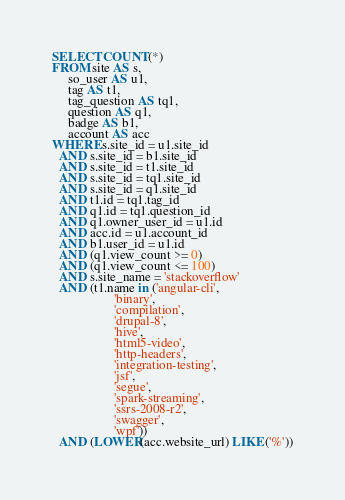Convert code to text. <code><loc_0><loc_0><loc_500><loc_500><_SQL_>SELECT COUNT(*)
FROM site AS s,
     so_user AS u1,
     tag AS t1,
     tag_question AS tq1,
     question AS q1,
     badge AS b1,
     account AS acc
WHERE s.site_id = u1.site_id
  AND s.site_id = b1.site_id
  AND s.site_id = t1.site_id
  AND s.site_id = tq1.site_id
  AND s.site_id = q1.site_id
  AND t1.id = tq1.tag_id
  AND q1.id = tq1.question_id
  AND q1.owner_user_id = u1.id
  AND acc.id = u1.account_id
  AND b1.user_id = u1.id
  AND (q1.view_count >= 0)
  AND (q1.view_count <= 100)
  AND s.site_name = 'stackoverflow'
  AND (t1.name in ('angular-cli',
                   'binary',
                   'compilation',
                   'drupal-8',
                   'hive',
                   'html5-video',
                   'http-headers',
                   'integration-testing',
                   'jsf',
                   'segue',
                   'spark-streaming',
                   'ssrs-2008-r2',
                   'swagger',
                   'wpf'))
  AND (LOWER(acc.website_url) LIKE ('%'))</code> 